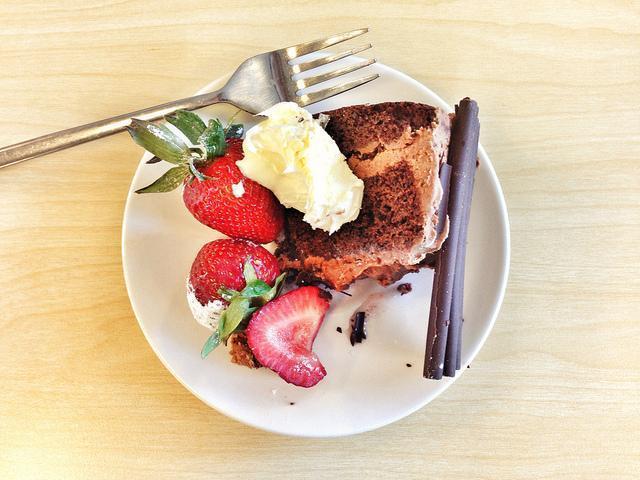Verify the accuracy of this image caption: "The cake is in the middle of the dining table.".
Answer yes or no. No. 